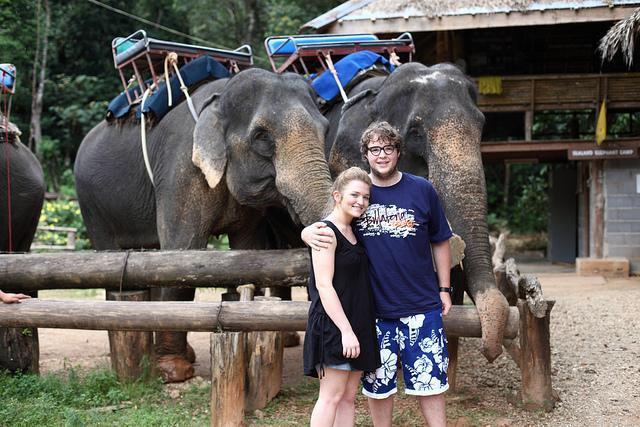How many people are there?
Give a very brief answer. 2. How many elephants can be seen?
Give a very brief answer. 3. How many benches are visible?
Give a very brief answer. 2. 